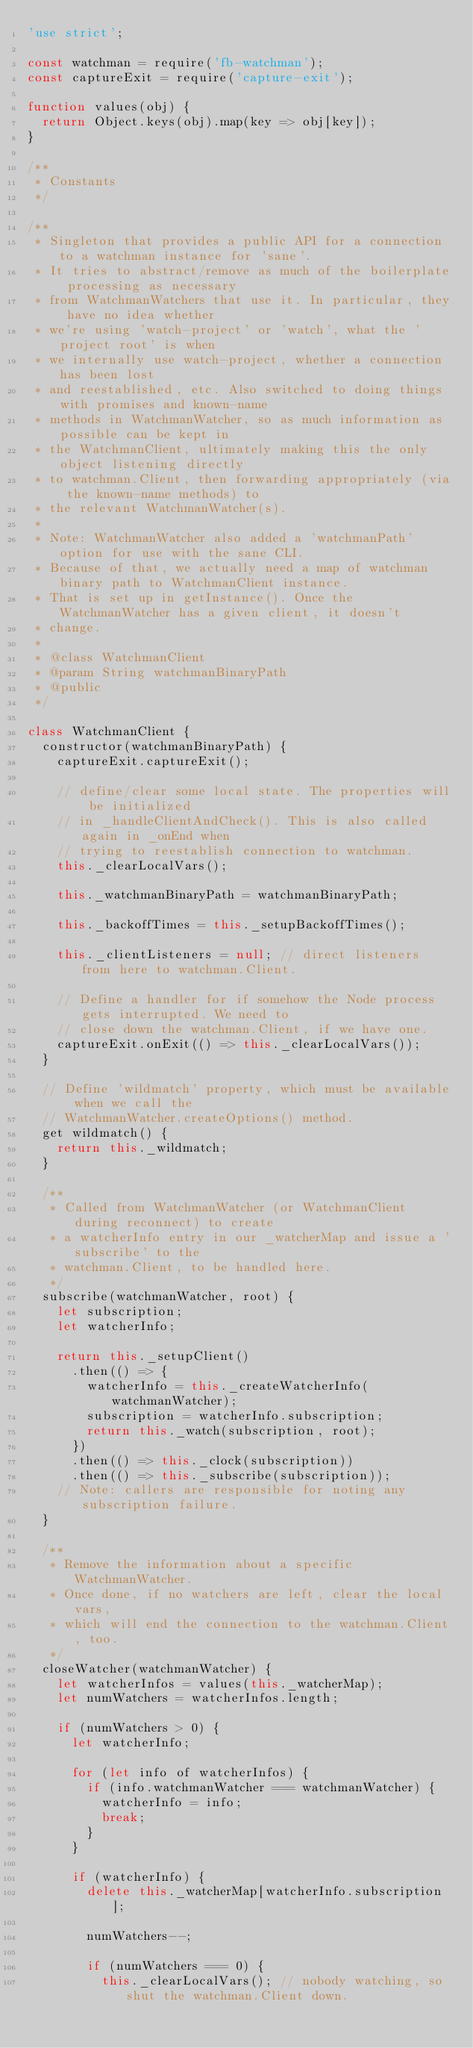<code> <loc_0><loc_0><loc_500><loc_500><_JavaScript_>'use strict';

const watchman = require('fb-watchman');
const captureExit = require('capture-exit');

function values(obj) {
  return Object.keys(obj).map(key => obj[key]);
}

/**
 * Constants
 */

/**
 * Singleton that provides a public API for a connection to a watchman instance for 'sane'.
 * It tries to abstract/remove as much of the boilerplate processing as necessary
 * from WatchmanWatchers that use it. In particular, they have no idea whether
 * we're using 'watch-project' or 'watch', what the 'project root' is when
 * we internally use watch-project, whether a connection has been lost
 * and reestablished, etc. Also switched to doing things with promises and known-name
 * methods in WatchmanWatcher, so as much information as possible can be kept in
 * the WatchmanClient, ultimately making this the only object listening directly
 * to watchman.Client, then forwarding appropriately (via the known-name methods) to
 * the relevant WatchmanWatcher(s).
 *
 * Note: WatchmanWatcher also added a 'watchmanPath' option for use with the sane CLI.
 * Because of that, we actually need a map of watchman binary path to WatchmanClient instance.
 * That is set up in getInstance(). Once the WatchmanWatcher has a given client, it doesn't
 * change.
 *
 * @class WatchmanClient
 * @param String watchmanBinaryPath
 * @public
 */

class WatchmanClient {
  constructor(watchmanBinaryPath) {
    captureExit.captureExit();

    // define/clear some local state. The properties will be initialized
    // in _handleClientAndCheck(). This is also called again in _onEnd when
    // trying to reestablish connection to watchman.
    this._clearLocalVars();

    this._watchmanBinaryPath = watchmanBinaryPath;

    this._backoffTimes = this._setupBackoffTimes();

    this._clientListeners = null; // direct listeners from here to watchman.Client.

    // Define a handler for if somehow the Node process gets interrupted. We need to
    // close down the watchman.Client, if we have one.
    captureExit.onExit(() => this._clearLocalVars());
  }

  // Define 'wildmatch' property, which must be available when we call the
  // WatchmanWatcher.createOptions() method.
  get wildmatch() {
    return this._wildmatch;
  }

  /**
   * Called from WatchmanWatcher (or WatchmanClient during reconnect) to create
   * a watcherInfo entry in our _watcherMap and issue a 'subscribe' to the
   * watchman.Client, to be handled here.
   */
  subscribe(watchmanWatcher, root) {
    let subscription;
    let watcherInfo;

    return this._setupClient()
      .then(() => {
        watcherInfo = this._createWatcherInfo(watchmanWatcher);
        subscription = watcherInfo.subscription;
        return this._watch(subscription, root);
      })
      .then(() => this._clock(subscription))
      .then(() => this._subscribe(subscription));
    // Note: callers are responsible for noting any subscription failure.
  }

  /**
   * Remove the information about a specific WatchmanWatcher.
   * Once done, if no watchers are left, clear the local vars,
   * which will end the connection to the watchman.Client, too.
   */
  closeWatcher(watchmanWatcher) {
    let watcherInfos = values(this._watcherMap);
    let numWatchers = watcherInfos.length;

    if (numWatchers > 0) {
      let watcherInfo;

      for (let info of watcherInfos) {
        if (info.watchmanWatcher === watchmanWatcher) {
          watcherInfo = info;
          break;
        }
      }

      if (watcherInfo) {
        delete this._watcherMap[watcherInfo.subscription];

        numWatchers--;

        if (numWatchers === 0) {
          this._clearLocalVars(); // nobody watching, so shut the watchman.Client down.</code> 